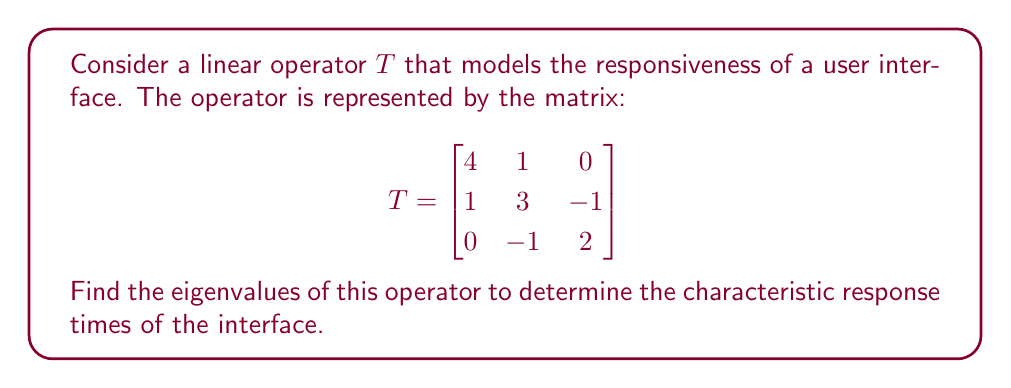Give your solution to this math problem. To find the eigenvalues of the linear operator $T$, we need to solve the characteristic equation:

$$\det(T - \lambda I) = 0$$

where $\lambda$ represents the eigenvalues and $I$ is the $3 \times 3$ identity matrix.

Step 1: Set up the characteristic equation:

$$\det\begin{pmatrix}
4-\lambda & 1 & 0 \\
1 & 3-\lambda & -1 \\
0 & -1 & 2-\lambda
\end{pmatrix} = 0$$

Step 2: Expand the determinant:

$$(4-\lambda)[(3-\lambda)(2-\lambda) + 1] - 1[1(2-\lambda) - 0] + 0 = 0$$

Step 3: Simplify:

$$(4-\lambda)[(3-\lambda)(2-\lambda) + 1] - (2-\lambda) = 0$$
$$(4-\lambda)(6-5\lambda+\lambda^2 + 1) - (2-\lambda) = 0$$
$$(4-\lambda)(7-5\lambda+\lambda^2) - (2-\lambda) = 0$$

Step 4: Expand:

$$28 - 20\lambda + 4\lambda^2 - 7\lambda + 5\lambda^2 - \lambda^3 - 2 + \lambda = 0$$

Step 5: Collect terms:

$$-\lambda^3 + 9\lambda^2 - 26\lambda + 26 = 0$$

Step 6: Factor the cubic equation:

$$-(\lambda - 2)(\lambda - 3)(\lambda - 4) = 0$$

Step 7: Solve for $\lambda$:

$$\lambda = 2, 3, \text{ or } 4$$

These are the eigenvalues of the linear operator $T$.
Answer: The eigenvalues of the linear operator $T$ are $\lambda_1 = 2$, $\lambda_2 = 3$, and $\lambda_3 = 4$. 